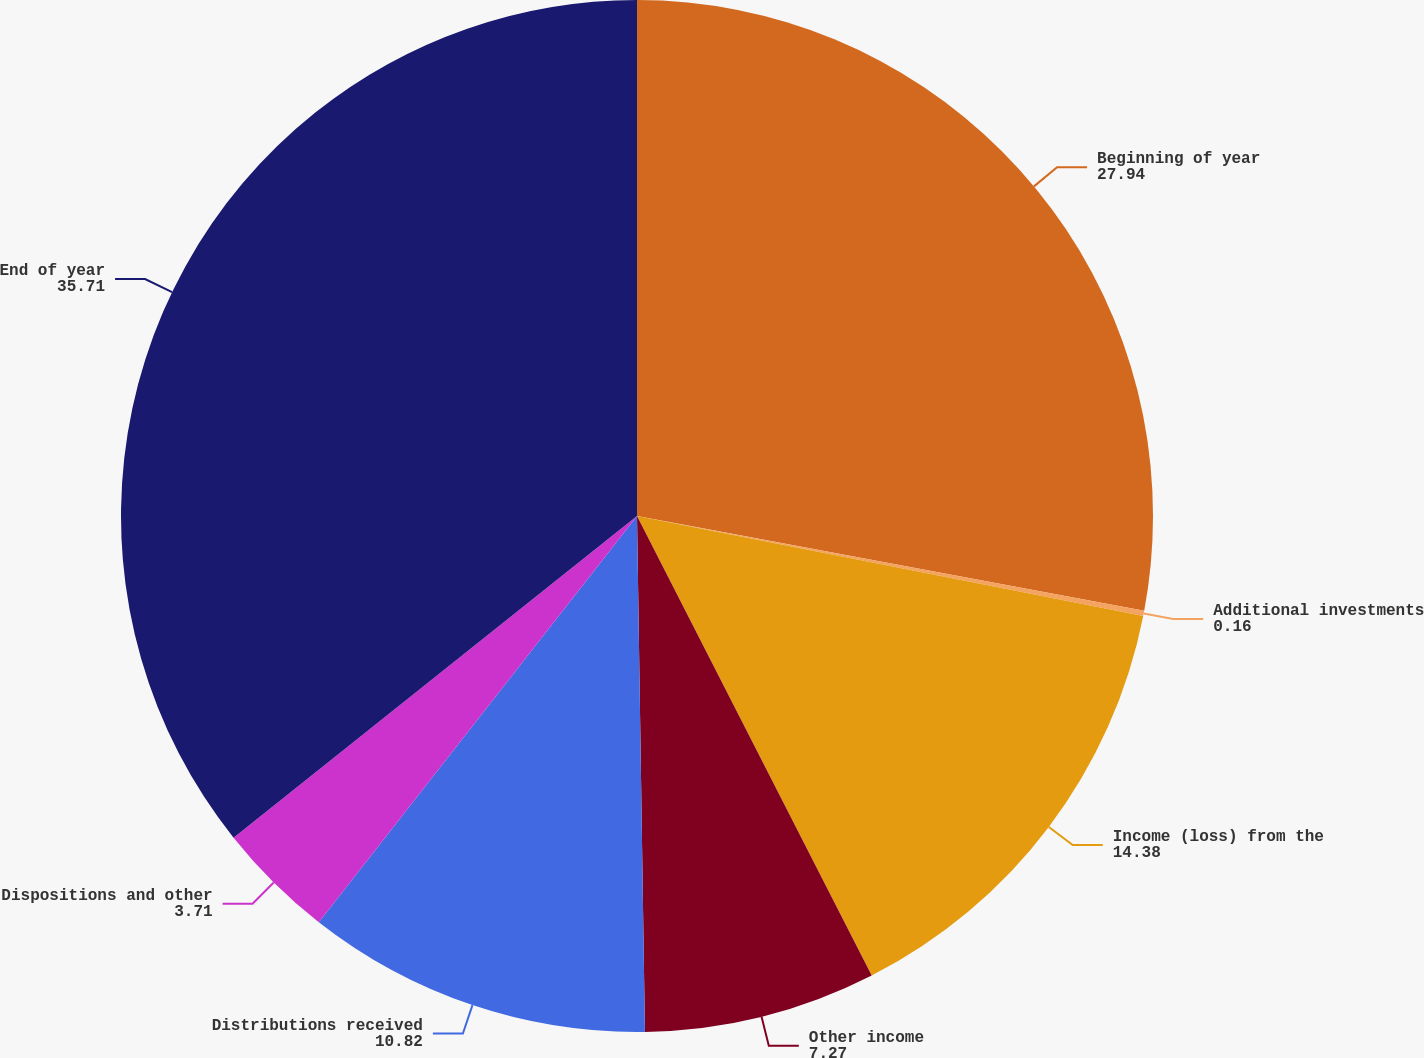Convert chart to OTSL. <chart><loc_0><loc_0><loc_500><loc_500><pie_chart><fcel>Beginning of year<fcel>Additional investments<fcel>Income (loss) from the<fcel>Other income<fcel>Distributions received<fcel>Dispositions and other<fcel>End of year<nl><fcel>27.94%<fcel>0.16%<fcel>14.38%<fcel>7.27%<fcel>10.82%<fcel>3.71%<fcel>35.71%<nl></chart> 